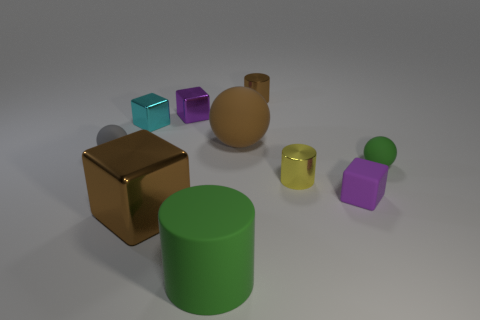Subtract all blocks. How many objects are left? 6 Add 3 purple rubber cubes. How many purple rubber cubes are left? 4 Add 3 gray cylinders. How many gray cylinders exist? 3 Subtract 0 blue spheres. How many objects are left? 10 Subtract all blue metal cylinders. Subtract all small cyan blocks. How many objects are left? 9 